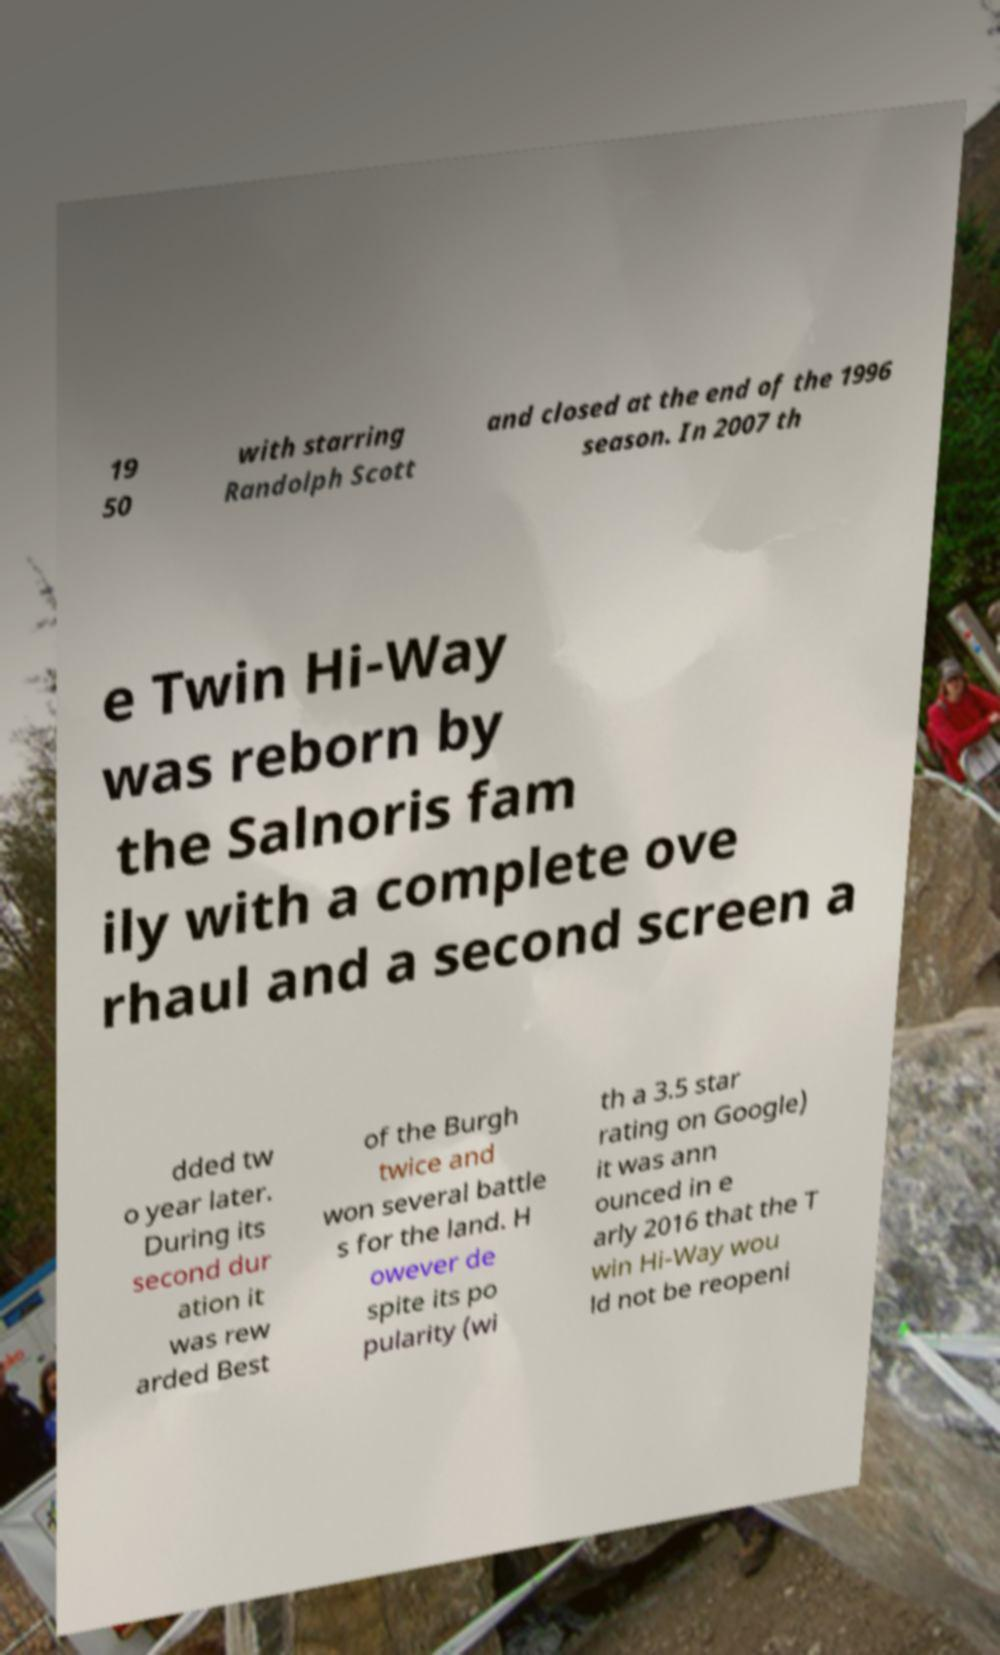What messages or text are displayed in this image? I need them in a readable, typed format. 19 50 with starring Randolph Scott and closed at the end of the 1996 season. In 2007 th e Twin Hi-Way was reborn by the Salnoris fam ily with a complete ove rhaul and a second screen a dded tw o year later. During its second dur ation it was rew arded Best of the Burgh twice and won several battle s for the land. H owever de spite its po pularity (wi th a 3.5 star rating on Google) it was ann ounced in e arly 2016 that the T win Hi-Way wou ld not be reopeni 